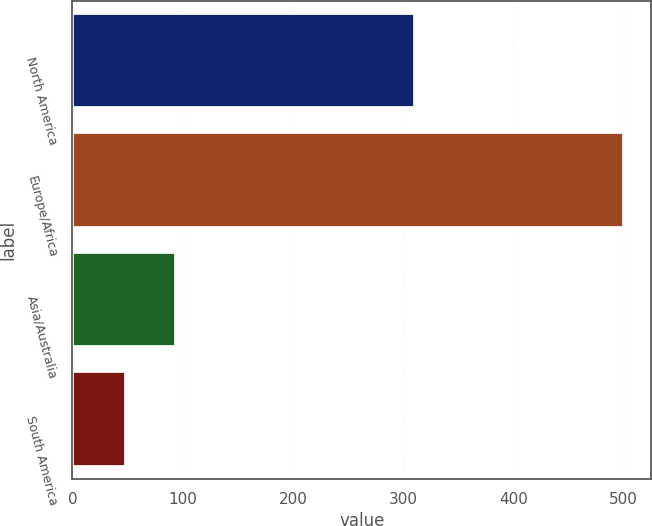Convert chart to OTSL. <chart><loc_0><loc_0><loc_500><loc_500><bar_chart><fcel>North America<fcel>Europe/Africa<fcel>Asia/Australia<fcel>South America<nl><fcel>311<fcel>500<fcel>94.1<fcel>49<nl></chart> 